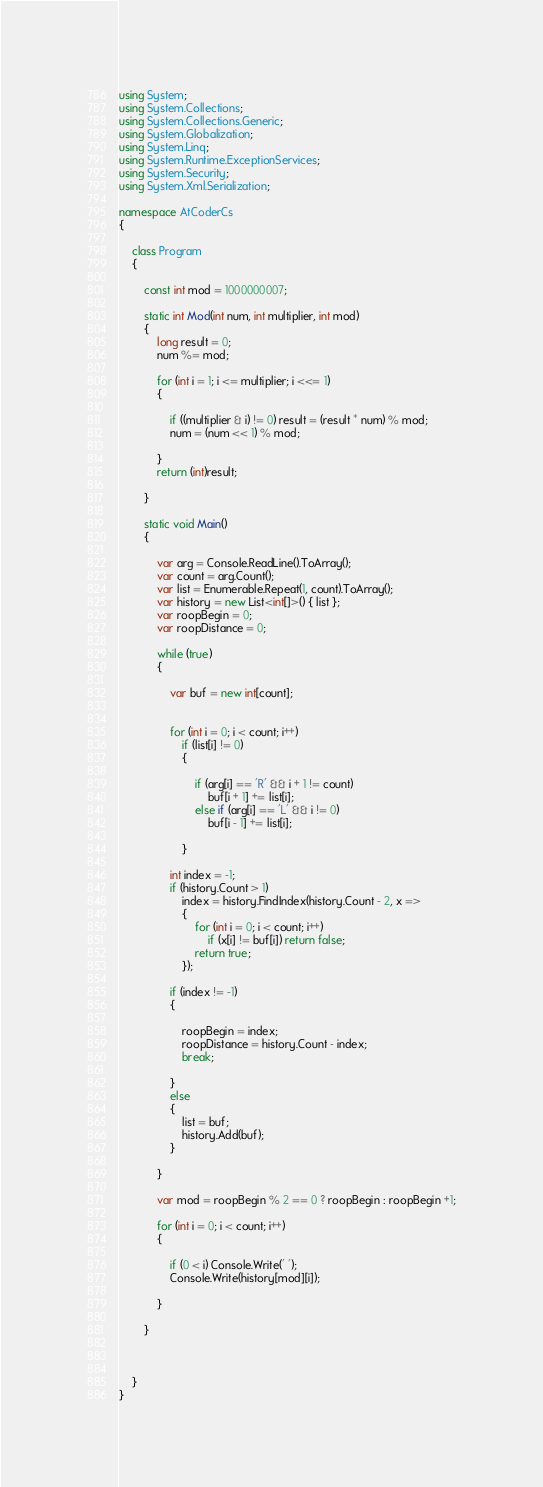<code> <loc_0><loc_0><loc_500><loc_500><_C#_>using System;
using System.Collections;
using System.Collections.Generic;
using System.Globalization;
using System.Linq;
using System.Runtime.ExceptionServices;
using System.Security;
using System.Xml.Serialization;

namespace AtCoderCs
{

    class Program
    {

        const int mod = 1000000007;

        static int Mod(int num, int multiplier, int mod)
        {
            long result = 0;
            num %= mod;

            for (int i = 1; i <= multiplier; i <<= 1)
            {

                if ((multiplier & i) != 0) result = (result * num) % mod;
                num = (num << 1) % mod;

            }
            return (int)result;

        }

        static void Main()
        {

            var arg = Console.ReadLine().ToArray();
            var count = arg.Count();
            var list = Enumerable.Repeat(1, count).ToArray();
            var history = new List<int[]>() { list };
            var roopBegin = 0;
            var roopDistance = 0;

            while (true)
            {

                var buf = new int[count];

                
                for (int i = 0; i < count; i++)
                    if (list[i] != 0)
                    {

                        if (arg[i] == 'R' && i + 1 != count)
                            buf[i + 1] += list[i];
                        else if (arg[i] == 'L' && i != 0)
                            buf[i - 1] += list[i];

                    }

                int index = -1;
                if (history.Count > 1)
                    index = history.FindIndex(history.Count - 2, x =>
                    {
                        for (int i = 0; i < count; i++)
                            if (x[i] != buf[i]) return false;
                        return true;
                    });

                if (index != -1)
                {

                    roopBegin = index;
                    roopDistance = history.Count - index;
                    break;

                }
                else
                {
                    list = buf;
                    history.Add(buf);
                }

            }

            var mod = roopBegin % 2 == 0 ? roopBegin : roopBegin +1;

            for (int i = 0; i < count; i++)
            {

                if (0 < i) Console.Write(' ');
                Console.Write(history[mod][i]);

            }

        }



    }
}
</code> 